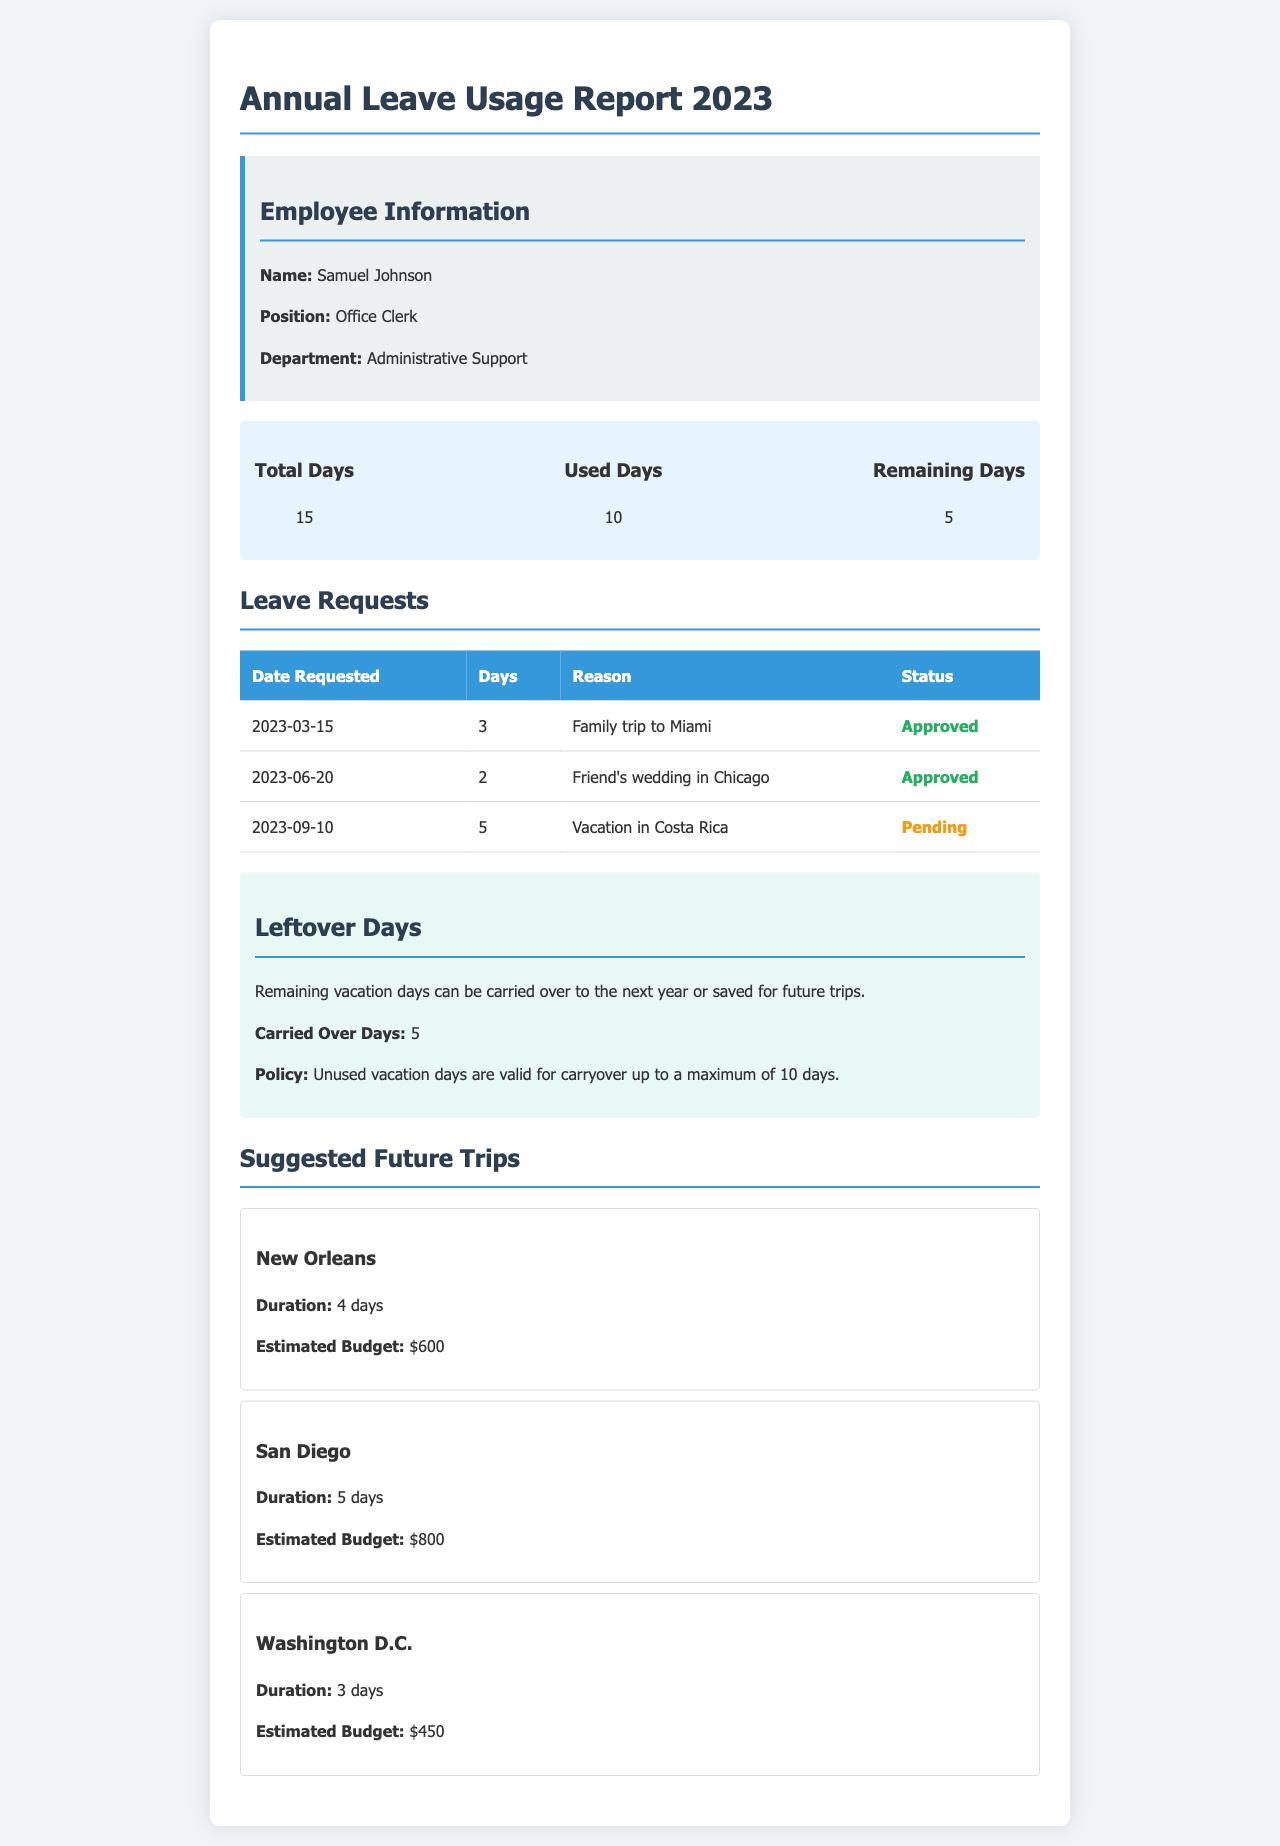what is the total number of vacation days? The total number of vacation days listed in the document is 15.
Answer: 15 how many vacation days have been used? The document states that 10 vacation days have been used.
Answer: 10 how many vacation days remain? According to the report, there are 5 remaining vacation days.
Answer: 5 what is the status of the vacation request for Costa Rica? The status for the vacation request for Costa Rica is mentioned as pending.
Answer: Pending how many days are approved for the family trip to Miami? The document shows that 3 days were approved for the family trip to Miami.
Answer: 3 how many leftover days can be carried over to next year? The report states that 5 leftover days can be carried over.
Answer: 5 what is the maximum number of unused vacation days allowed for carryover? The maximum number of unused vacation days allowed for carryover is 10 days.
Answer: 10 what is the estimated budget for a trip to San Diego? The estimated budget for the trip to San Diego is $800.
Answer: $800 how long is the suggested trip to Washington D.C.? The suggested trip to Washington D.C. is for 3 days.
Answer: 3 days 